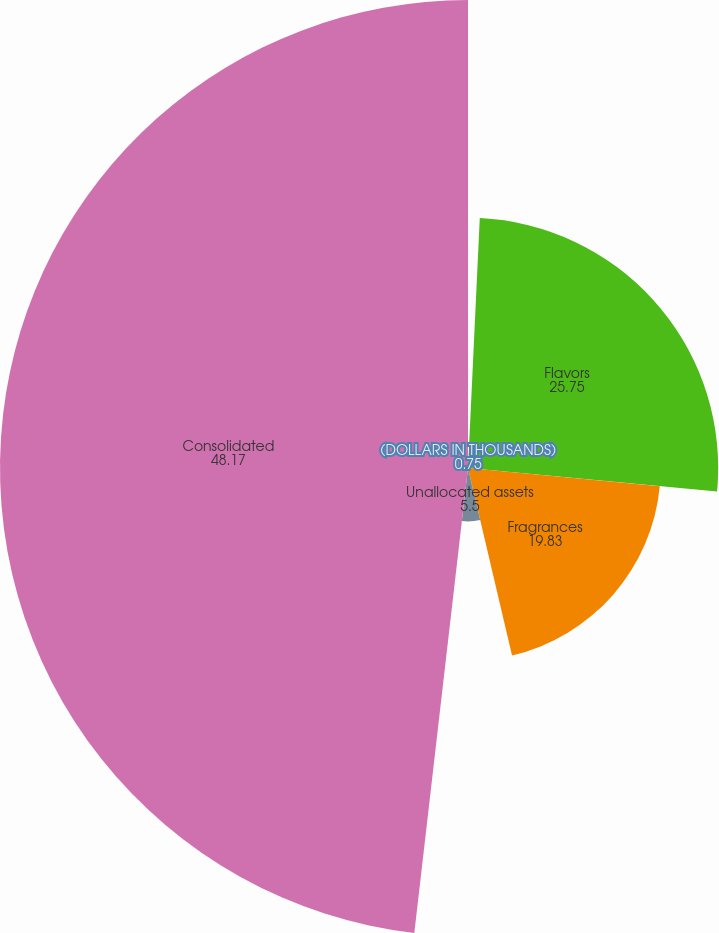Convert chart. <chart><loc_0><loc_0><loc_500><loc_500><pie_chart><fcel>(DOLLARS IN THOUSANDS)<fcel>Flavors<fcel>Fragrances<fcel>Unallocated assets<fcel>Consolidated<nl><fcel>0.75%<fcel>25.75%<fcel>19.83%<fcel>5.5%<fcel>48.17%<nl></chart> 